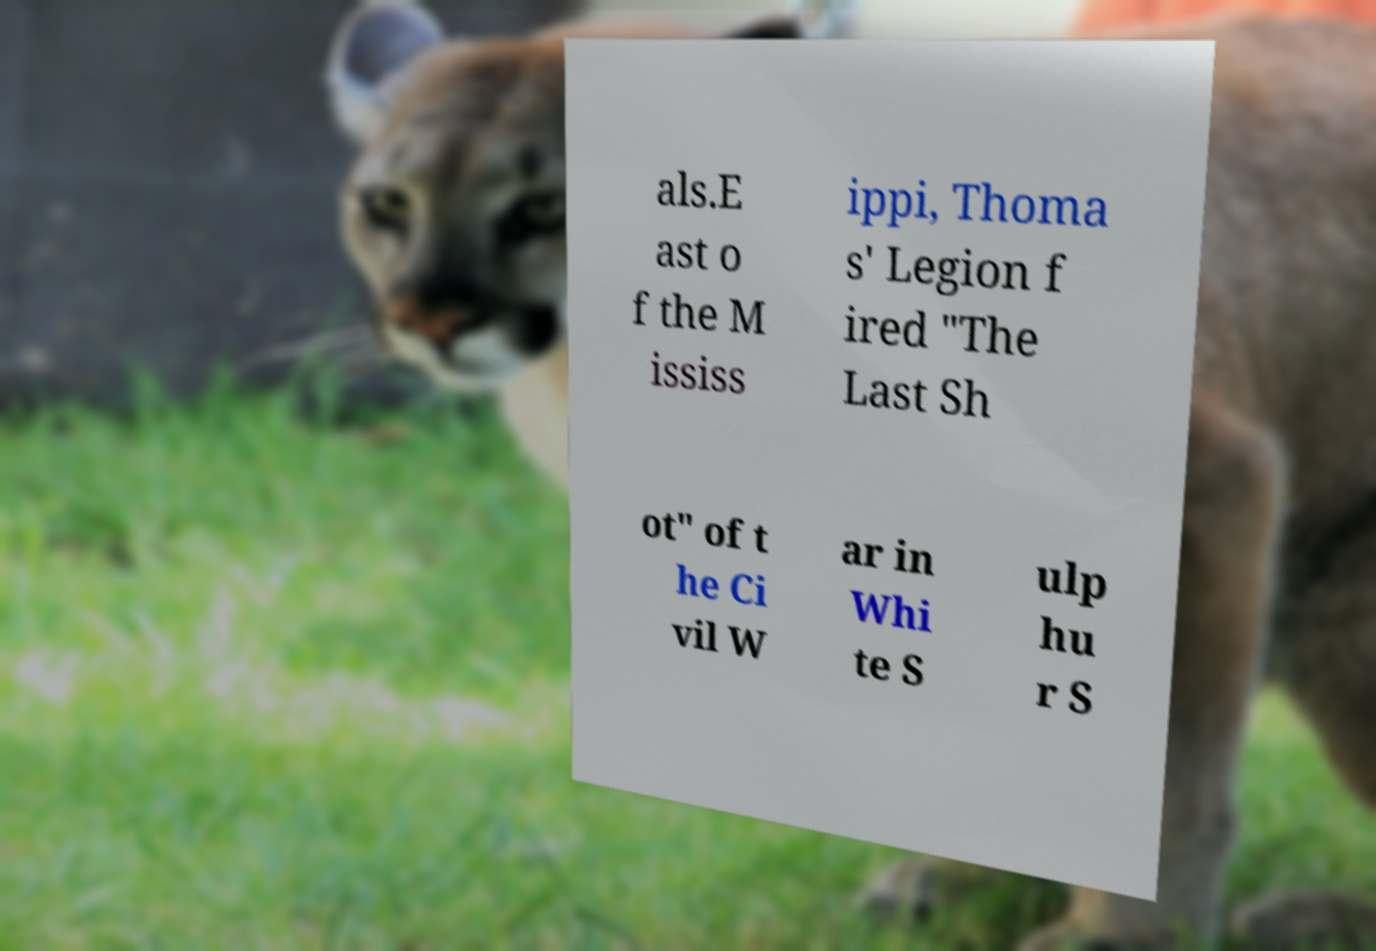Could you extract and type out the text from this image? als.E ast o f the M ississ ippi, Thoma s' Legion f ired "The Last Sh ot" of t he Ci vil W ar in Whi te S ulp hu r S 